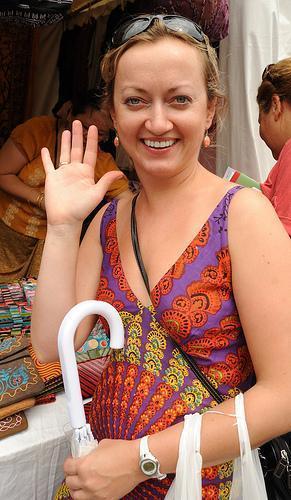How many fingers is she holding up?
Give a very brief answer. 5. How many people are in the picture?
Give a very brief answer. 3. 